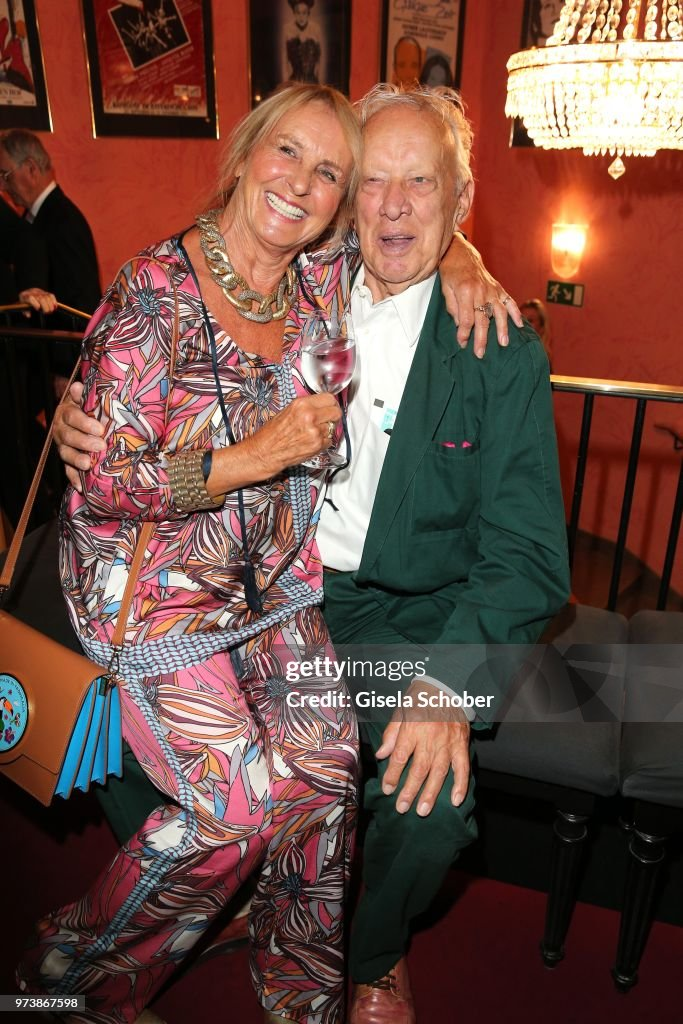Who else might be at the event, and what are they doing? The event is likely attended by a diverse group of individuals. Friends and family mingle around the room, engaged in animated conversations and hearty laughter. Artists and performers potentially showcase their talents, adding a dynamic rhythm to the atmosphere. Waitstaff move gracefully among the guests, serving drinks and hors d'oeuvres, while a soft background music plays, enhancing the joyous mood. Some guests are admiring the posters and chandeliers, discussing their intricate details and sharing personal anecdotes related to the art. The air is filled with a buzz of excitement, camaraderie, and a shared love for the cultural setting. What could be the highlight of this event? The highlight of the event might be a special performance or a heartfelt speech. A talented artist could be performing a piece that resonates deeply with the audience, or perhaps there is a heartfelt speech by a prominent figure in the arts community, acknowledging the efforts of everyone involved and sharing inspiring stories. The couple, with their meaningful contributions to the arts, could even be honored for their dedication and support. This moment of recognition and celebration would bring everyone together, reinforcing the sense of community and shared passion for the arts. 